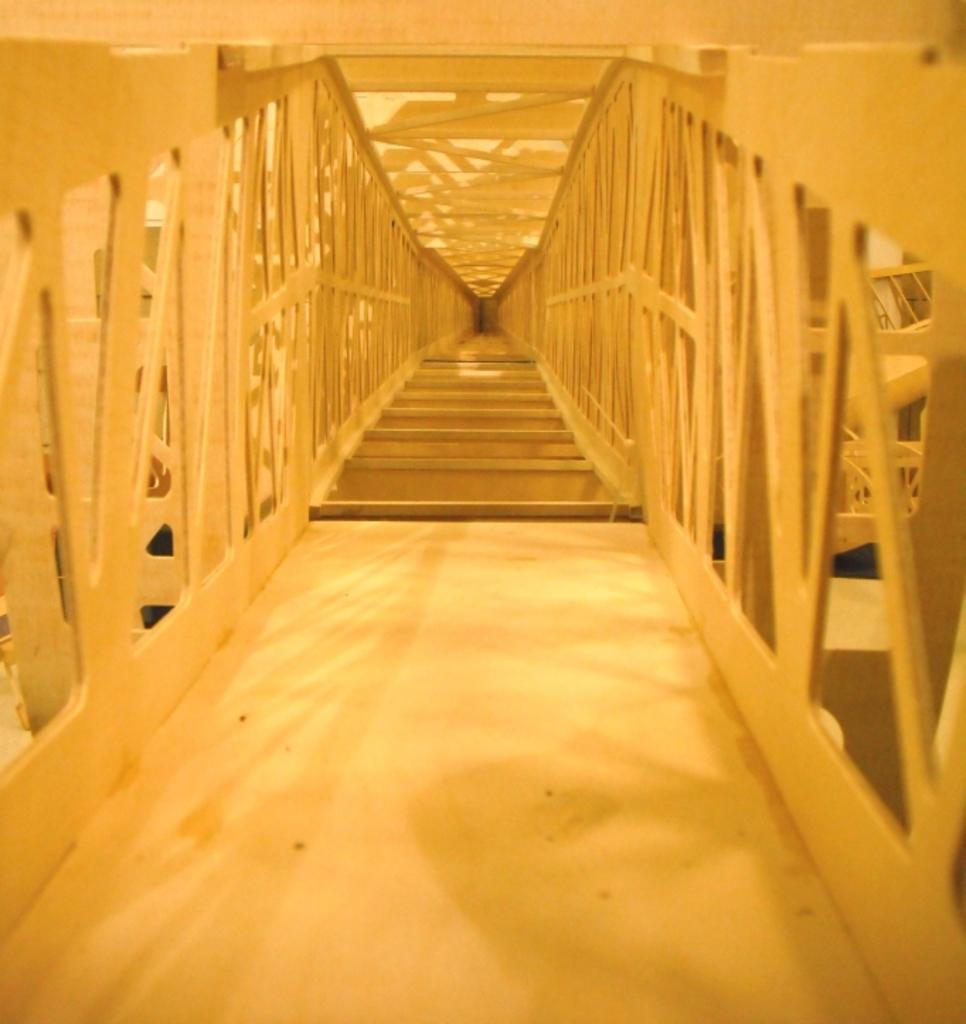What type of architectural feature is present in the image? There are steps in the image. What is used to enclose or separate an area in the image? There is a fence in the image. What other metal objects can be seen in the image? There are other metal objects in the image. What type of egg is being used by the band in the image? There is no band or egg present in the image. How does the volleyball affect the metal objects in the image? There is no volleyball present in the image, so it cannot affect the metal objects. 